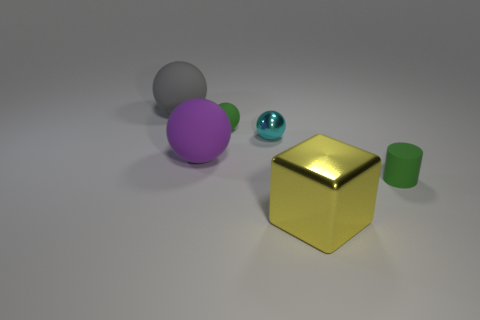Add 3 green balls. How many objects exist? 9 Subtract all blocks. How many objects are left? 5 Add 5 cyan things. How many cyan things are left? 6 Add 5 tiny green rubber things. How many tiny green rubber things exist? 7 Subtract 1 green spheres. How many objects are left? 5 Subtract all big balls. Subtract all yellow metallic cubes. How many objects are left? 3 